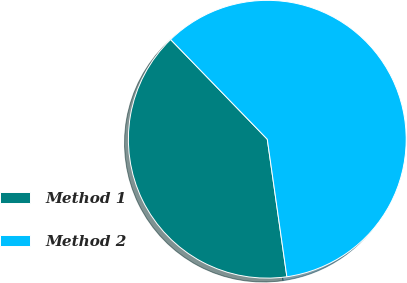<chart> <loc_0><loc_0><loc_500><loc_500><pie_chart><fcel>Method 1<fcel>Method 2<nl><fcel>40.0%<fcel>60.0%<nl></chart> 